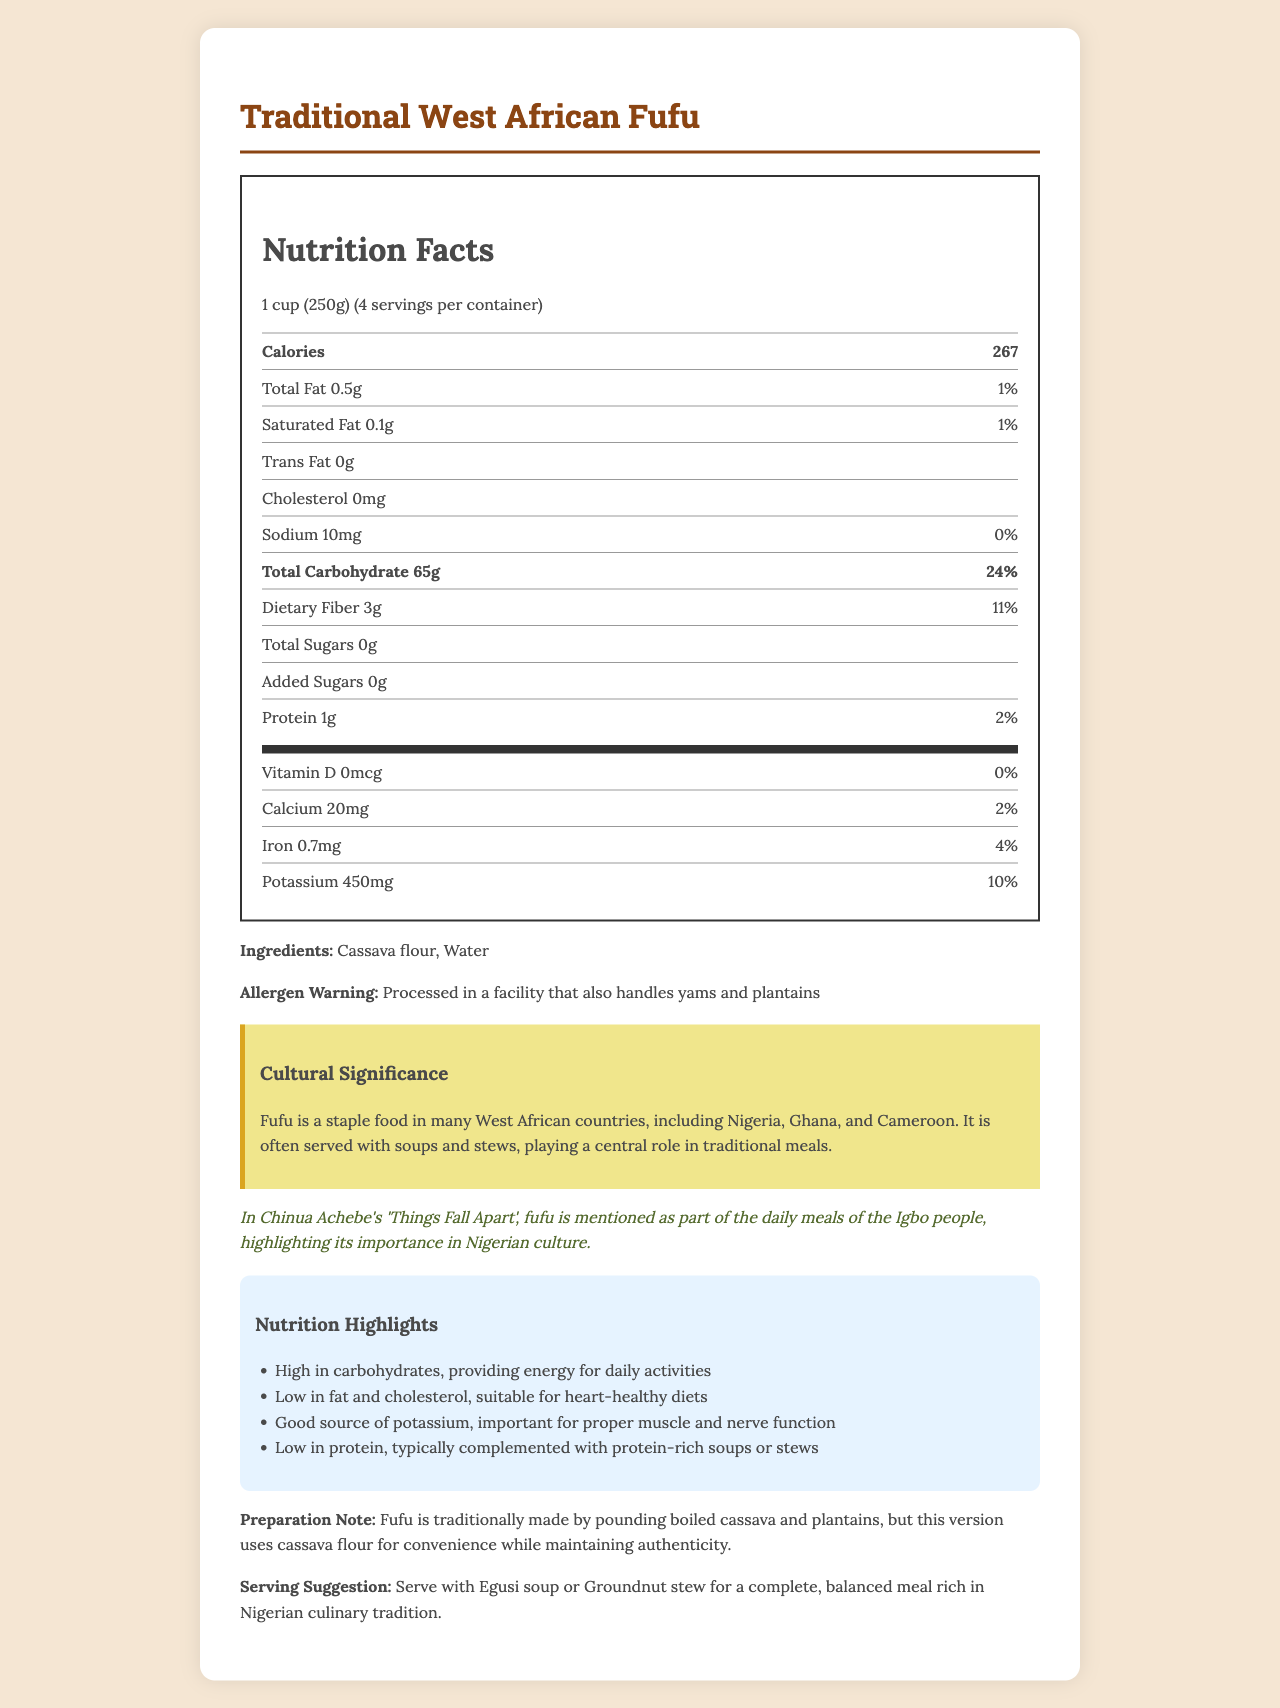what is the serving size? The document specifies the serving size of Traditional West African Fufu as 1 cup (250g).
Answer: 1 cup (250g) How many calories are in a single serving of fufu? The nutrition label indicates that a single serving of fufu contains 267 calories.
Answer: 267 What is the total carbohydrate content per serving? According to the nutrition facts, the total carbohydrate content per serving is 65g.
Answer: 65g What is the protein content per serving? The document lists the protein content per serving as 1g.
Answer: 1g What is the percent daily value of dietary fiber? The label shows that the percent daily value of dietary fiber per serving is 11%.
Answer: 11% Which ingredient makes up the majority of fufu? A. Plantains B. Cassava flour C. Yams D. Water The ingredients listed in the document are cassava flour and water, with cassava flour mentioned first, suggesting it is the primary ingredient.
Answer: B. Cassava flour How much potassium is in one serving? A. 100mg B. 450mg C. 200mg D. 300mg The nutrition facts indicate that each serving contains 450mg of potassium.
Answer: B. 450mg Does the fufu contain any added sugars? The nutrition label states that there are 0g of added sugars in the fufu.
Answer: No Is fufu low in fat content? The total fat content per serving is 0.5g, which is only 1% of the daily value, indicating it is low in fat.
Answer: Yes Summarize the main nutrition highlights of traditional West African fufu. The document highlights fufu's high carbohydrate and low protein content. It also notes its low fat and cholesterol, which is good for heart health, and its potassium content, which aids muscle and nerve function.
Answer: Traditional West African Fufu is high in carbohydrates and low in protein. It is also low in fat and cholesterol, making it suitable for heart-healthy diets. Additionally, it is a good source of potassium, which is important for proper muscle and nerve function. The fufu is low in protein and is typically complemented with protein-rich soups or stews. What is one traditional dish suggested to serve with fufu for a balanced meal? The serving suggestion in the document mentions serving fufu with Egusi soup or Groundnut stew for a balanced meal rich in Nigerian culinary tradition.
Answer: Egusi soup or Groundnut stew What is the allergen warning associated with fufu? The document contains an allergen warning, indicating that the fufu is processed in a facility that also handles yams and plantains.
Answer: Processed in a facility that also handles yams and plantains In which literary work is fufu mentioned as part of the daily meals of the Igbo people? The document references Chinua Achebe's 'Things Fall Apart', where fufu is mentioned as part of the Igbo people's daily meals.
Answer: Things Fall Apart Is there a significant amount of Vitamin D in fufu? The nutrition facts show that Vitamin D content is 0mcg per serving, indicating it is not present in significant amounts.
Answer: No What percentage of the daily recommended iron intake does one serving of fufu provide? According to the nutrition facts, one serving of fufu provides 4% of the daily recommended iron intake.
Answer: 4% What are traditional methods for preparing fufu? The preparation note mentions that fufu is traditionally made by pounding boiled cassava and plantains.
Answer: Pounding boiled cassava and plantains What year was the recipe for this version of fufu created? The document does not provide information regarding the year this version of fufu was created.
Answer: Cannot be determined 